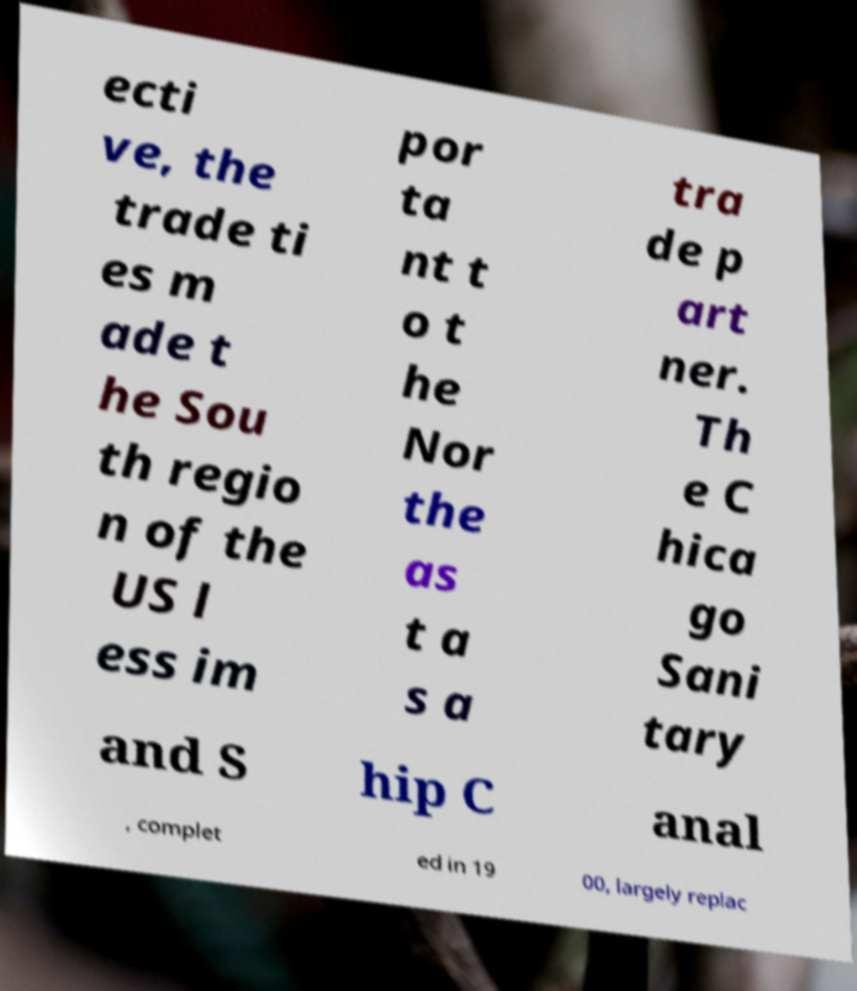Please read and relay the text visible in this image. What does it say? ecti ve, the trade ti es m ade t he Sou th regio n of the US l ess im por ta nt t o t he Nor the as t a s a tra de p art ner. Th e C hica go Sani tary and S hip C anal , complet ed in 19 00, largely replac 